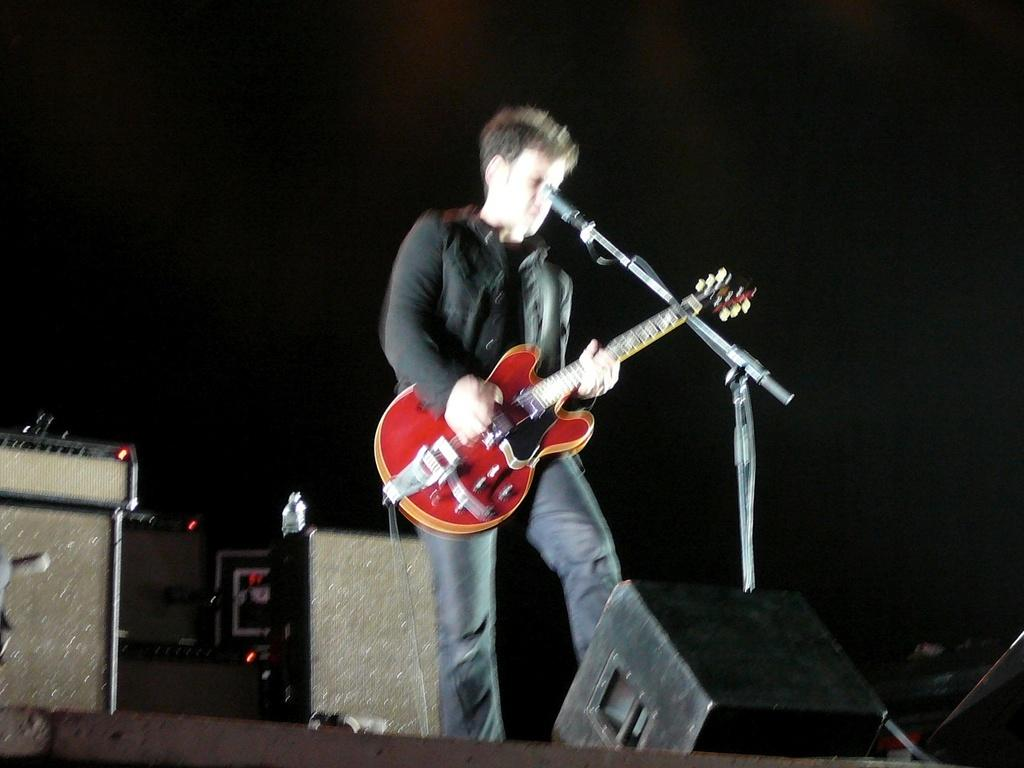What is the overall color scheme of the background in the image? The background of the picture is very dark. What objects can be seen in the image besides the man playing the guitar? There are devices and an amp in the image. What is the man wearing while playing the guitar? The man is wearing a black jacket. What piece of equipment is present to amplify the sound of the guitar? There is an amp in the image. How many jellyfish can be seen swimming in the background of the image? There are no jellyfish present in the image; the background is very dark. What type of distribution system is used for the devices in the image? There is no information about a distribution system for the devices in the image. 